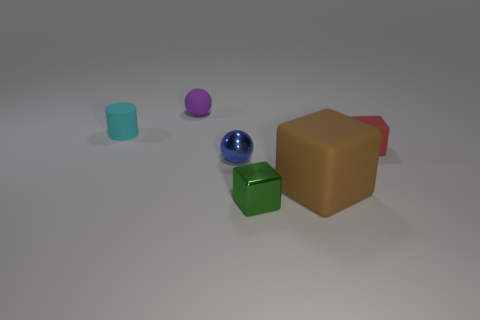What is the position of the blue metallic sphere in relation to the green cube? The blue metallic sphere is situated behind and to the right of the green cube from the viewer's perspective. 